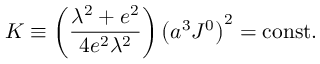<formula> <loc_0><loc_0><loc_500><loc_500>K \equiv \left ( { \frac { \lambda ^ { 2 } + e ^ { 2 } } { 4 e ^ { 2 } \lambda ^ { 2 } } } \right ) \left ( a ^ { 3 } J ^ { 0 } \right ) ^ { 2 } = c o n s t .</formula> 